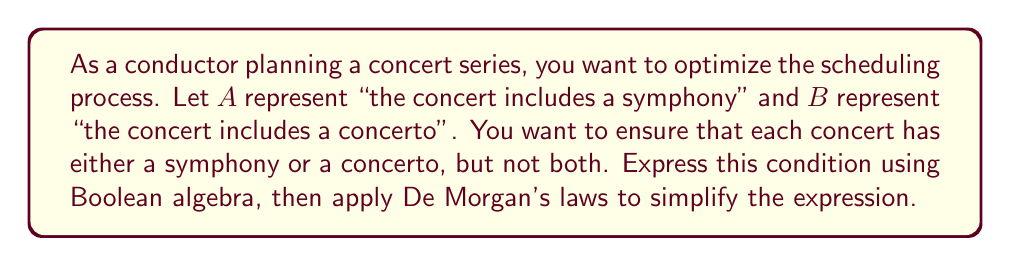Provide a solution to this math problem. Let's approach this step-by-step:

1) The condition "each concert has either a symphony or a concerto, but not both" can be expressed as:

   $$(A \lor B) \land \lnot(A \land B)$$

2) We can simplify this using De Morgan's laws. Let's focus on the second part:
   $\lnot(A \land B)$

3) Applying De Morgan's first law:
   $\lnot(A \land B) = \lnot A \lor \lnot B$

4) Now our expression becomes:
   $$(A \lor B) \land (\lnot A \lor \lnot B)$$

5) We can distribute the $\land$ over the $\lor$:
   $$(A \land \lnot A) \lor (A \land \lnot B) \lor (B \land \lnot A) \lor (B \land \lnot B)$$

6) Simplify:
   - $A \land \lnot A = 0$ (false)
   - $B \land \lnot B = 0$ (false)

7) Our expression reduces to:
   $$(A \land \lnot B) \lor (B \land \lnot A)$$

This final expression represents "either A or B, but not both" in its simplest form.
Answer: $(A \land \lnot B) \lor (B \land \lnot A)$ 